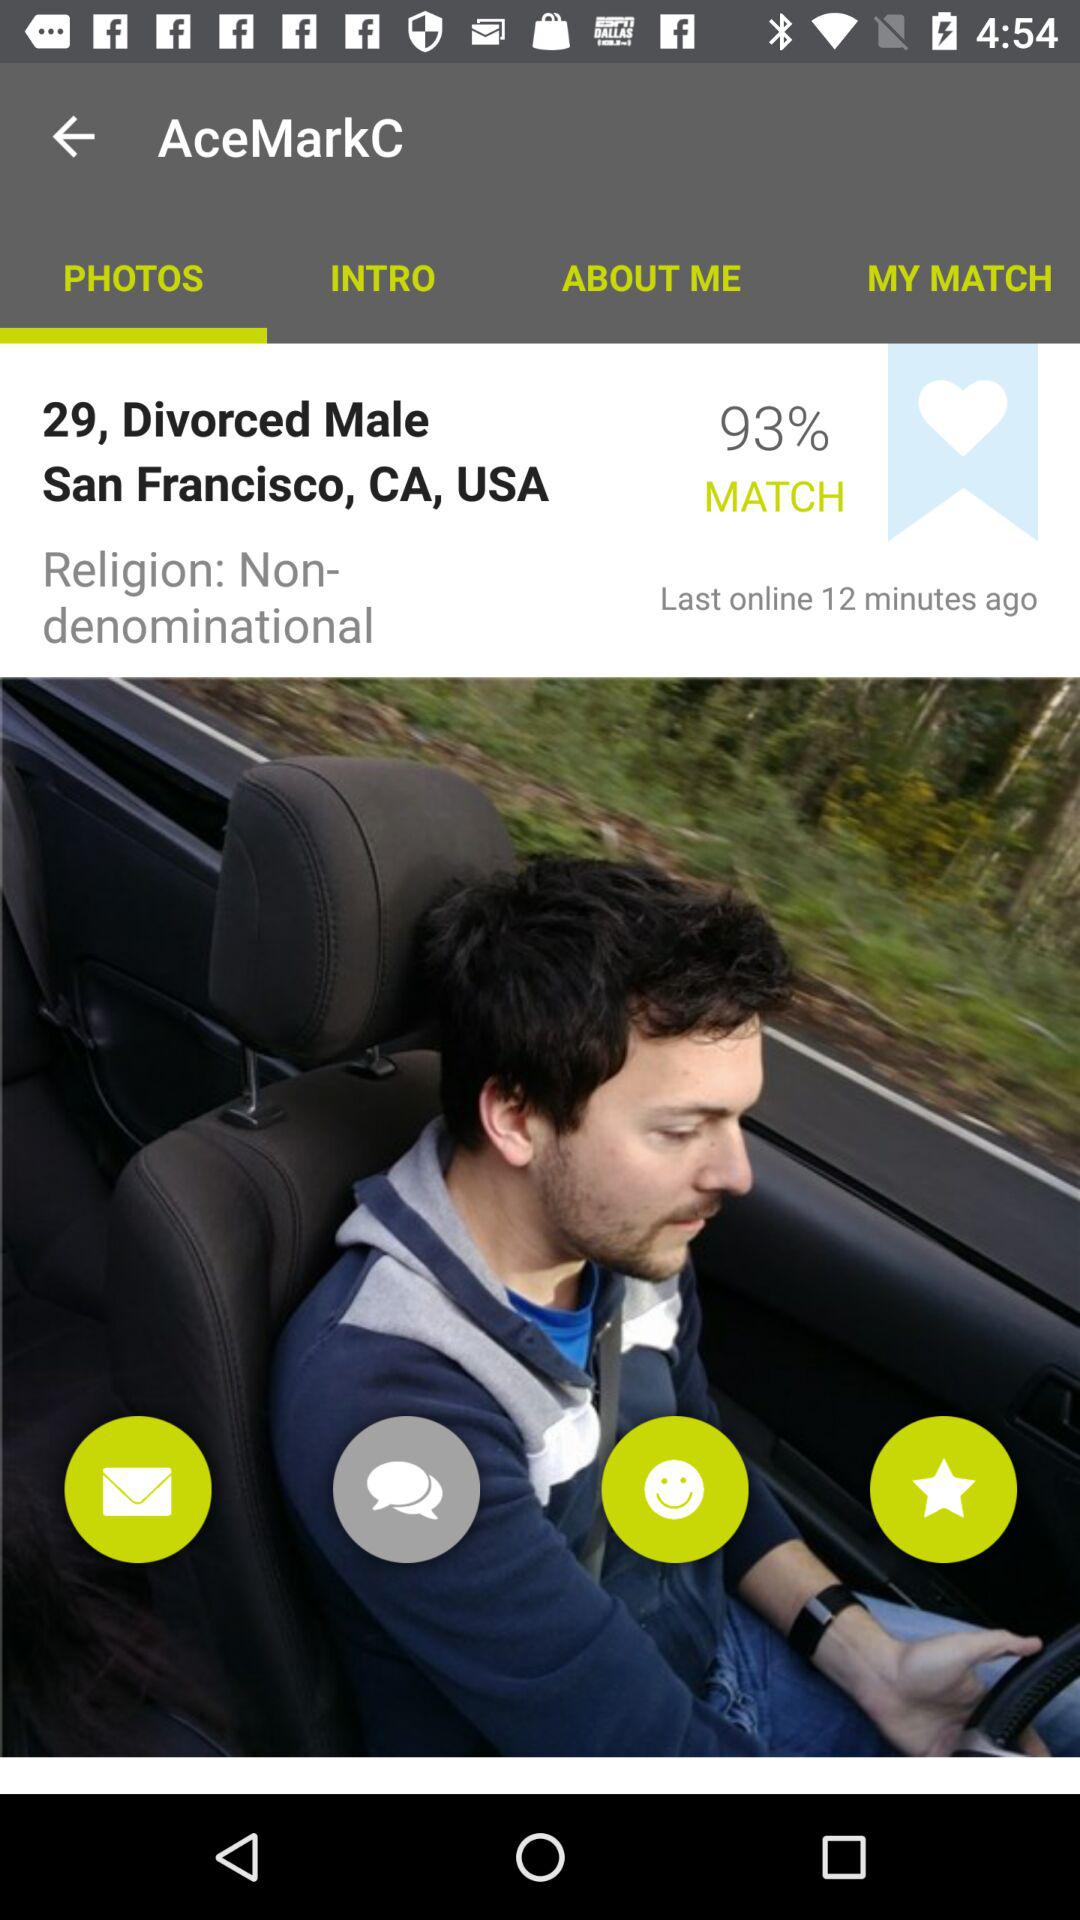What is the age given? The age is 29. 